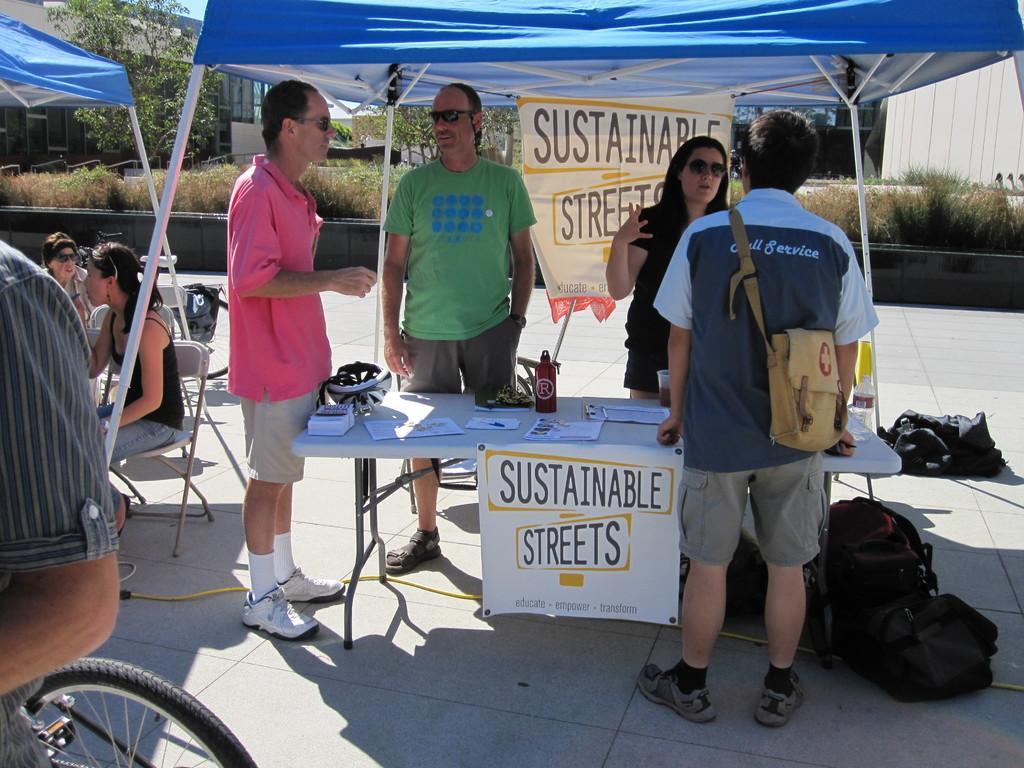Please provide a concise description of this image. In this image I can see group of people on the road, tents, tables, chairs and bags. In the background I can see a fence, grass, trees and buildings. This image is taken on the road. 